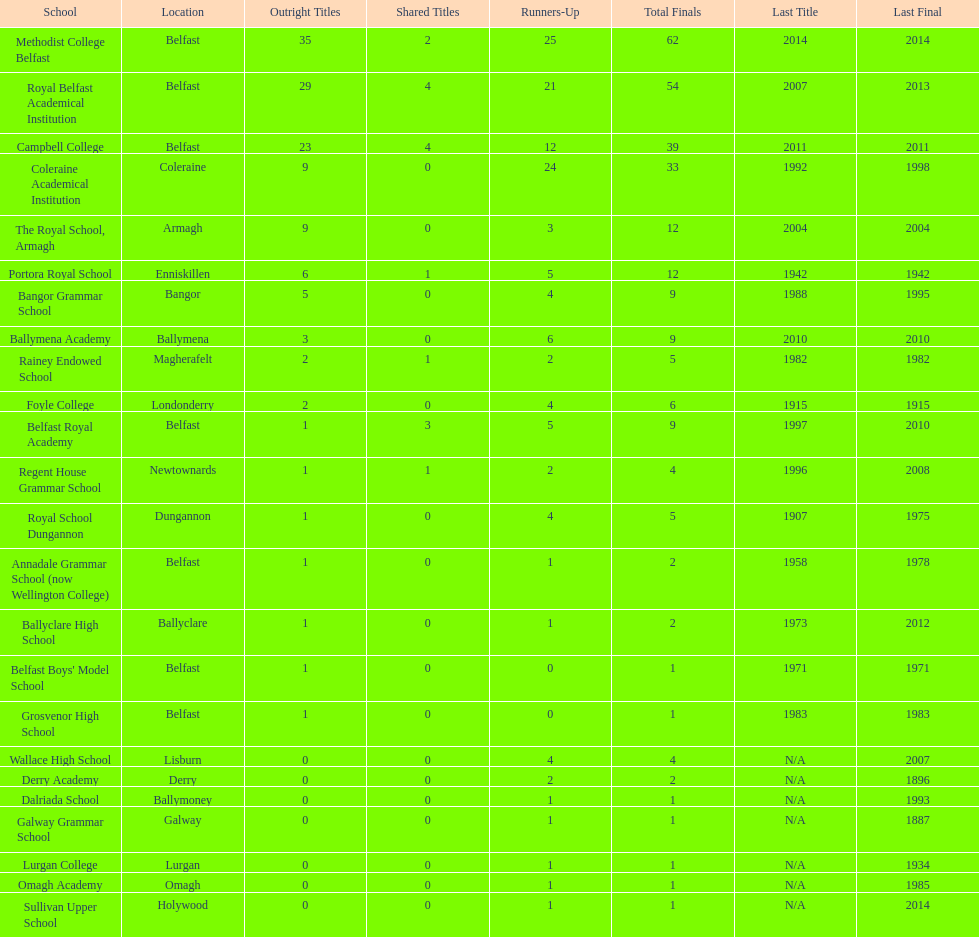How many schools held over 5 outright titles? 6. 